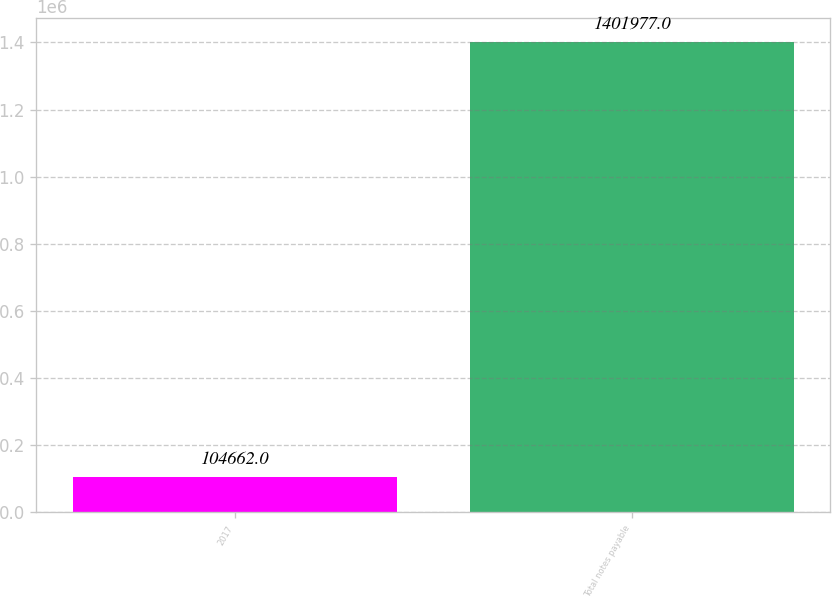Convert chart to OTSL. <chart><loc_0><loc_0><loc_500><loc_500><bar_chart><fcel>2017<fcel>Total notes payable<nl><fcel>104662<fcel>1.40198e+06<nl></chart> 